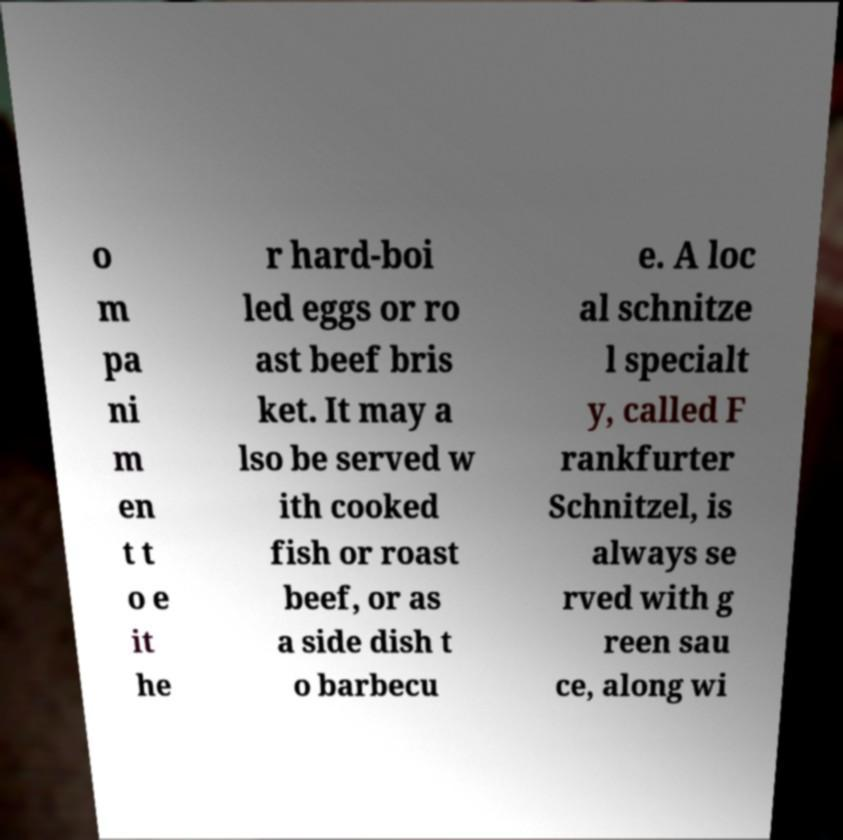Please identify and transcribe the text found in this image. o m pa ni m en t t o e it he r hard-boi led eggs or ro ast beef bris ket. It may a lso be served w ith cooked fish or roast beef, or as a side dish t o barbecu e. A loc al schnitze l specialt y, called F rankfurter Schnitzel, is always se rved with g reen sau ce, along wi 